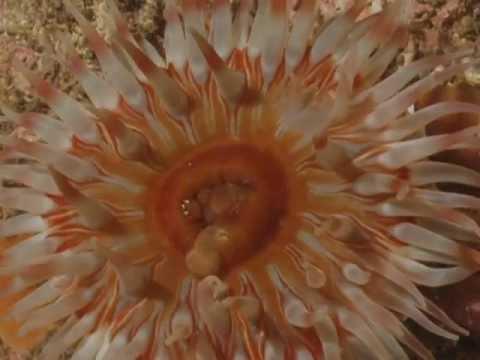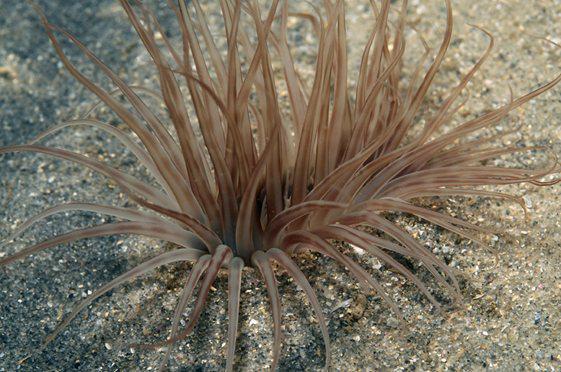The first image is the image on the left, the second image is the image on the right. For the images displayed, is the sentence "The left image contains one anemone, which has orangish color, tapered tendrils, and a darker center with a """"mouth"""" opening." factually correct? Answer yes or no. Yes. 